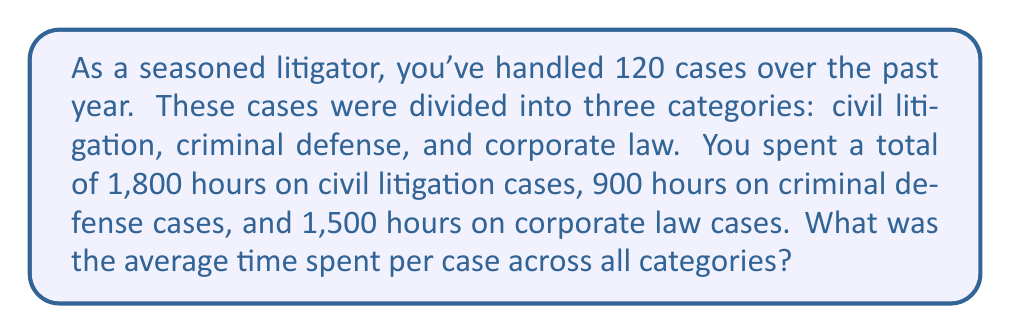Teach me how to tackle this problem. To solve this problem, we'll follow these steps:

1. Calculate the total number of hours spent on all cases:
   $$\text{Total hours} = 1,800 + 900 + 1,500 = 4,200 \text{ hours}$$

2. Recall that we have a total of 120 cases across all categories.

3. Calculate the average time per case using the formula:
   $$\text{Average time per case} = \frac{\text{Total hours}}{\text{Total number of cases}}$$

4. Plug in the values:
   $$\text{Average time per case} = \frac{4,200 \text{ hours}}{120 \text{ cases}}$$

5. Perform the division:
   $$\text{Average time per case} = 35 \text{ hours per case}$$

Therefore, on average, you spent 35 hours per case across all categories.
Answer: $35 \text{ hours per case}$ 